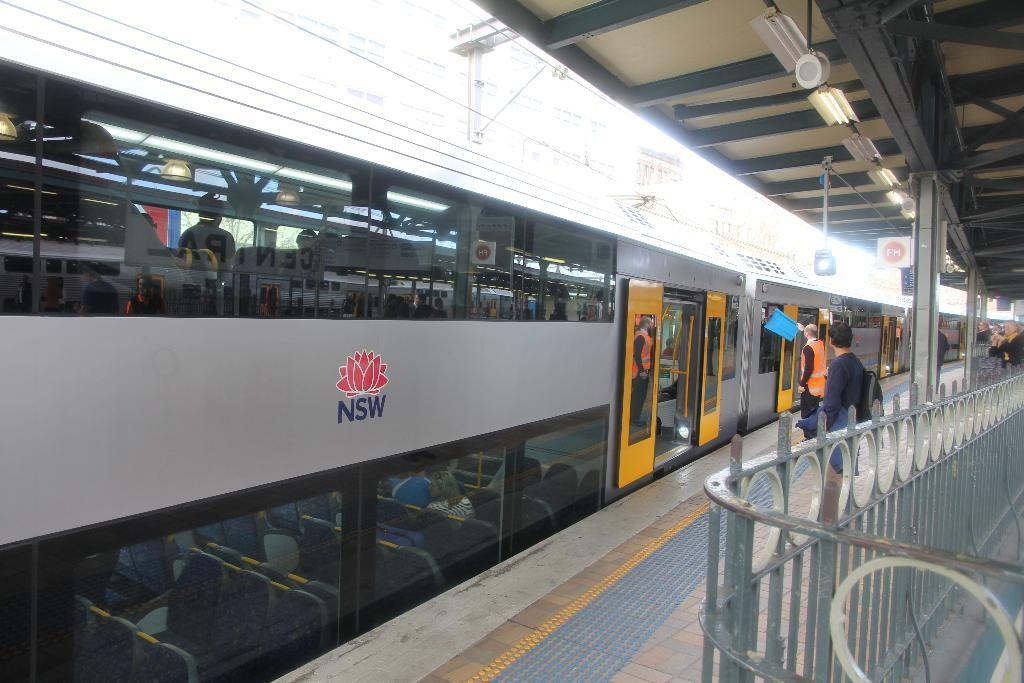What is the main subject of the image? The main subject of the image is a train. What can be seen inside the train? There are people sitting inside the train. What is happening on the platform next to the train? There are people standing on a platform. What structures are present in the image? There is a fence and wires in the image. What type of game is being played on the train in the image? There is no game being played on the train in the image. Can you see any lizards on the train or platform in the image? There are no lizards present in the image. 